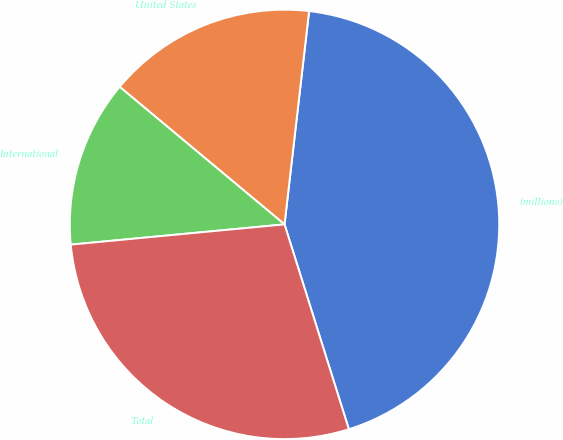<chart> <loc_0><loc_0><loc_500><loc_500><pie_chart><fcel>(millions)<fcel>United States<fcel>International<fcel>Total<nl><fcel>43.33%<fcel>15.76%<fcel>12.57%<fcel>28.34%<nl></chart> 